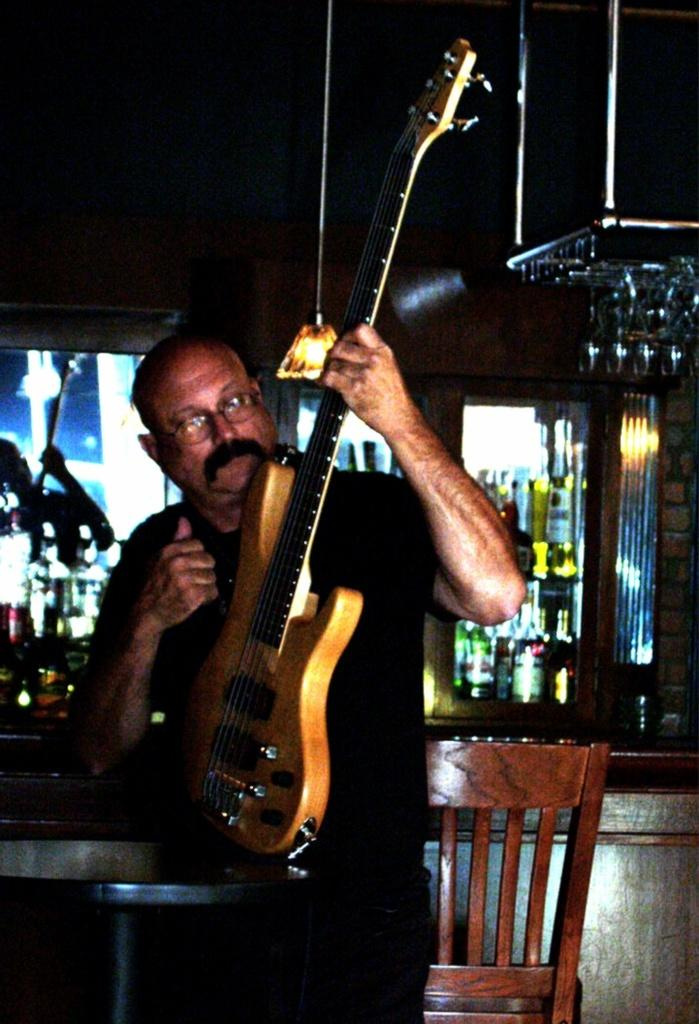Who is present in the image? There is a man in the image. What is the man holding in the image? The man is holding a guitar. What piece of furniture can be seen in the image? There is a chair in the image. What type of objects are present in the image? There are bottles in the image. What source of illumination is visible in the image? There is a light in the image. What type of bird can be seen singing a request in the image? There is no bird present in the image, and birds do not sing requests. 